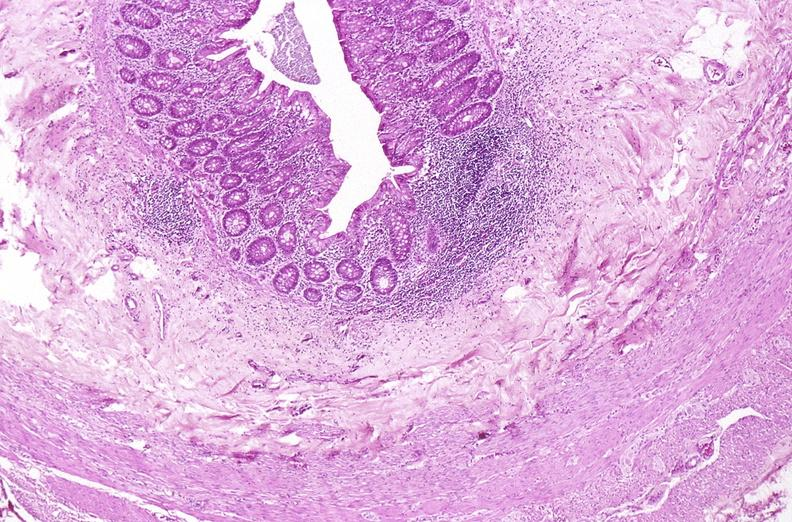does notochord show appendix, normal histology?
Answer the question using a single word or phrase. No 